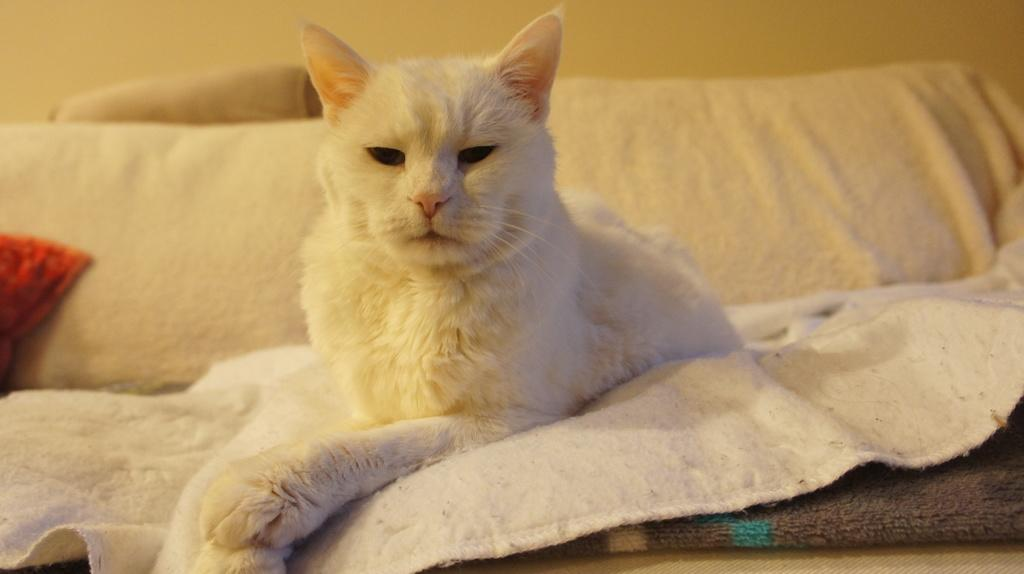What type of animal is in the image? There is a cat in the image. Where is the cat located? The cat is on a sofa. What color is the cat? The cat is white in color. What type of waves can be seen in the image? There are no waves present in the image; it features a white cat on a sofa. How many sticks are visible in the image? There are no sticks visible in the image. 